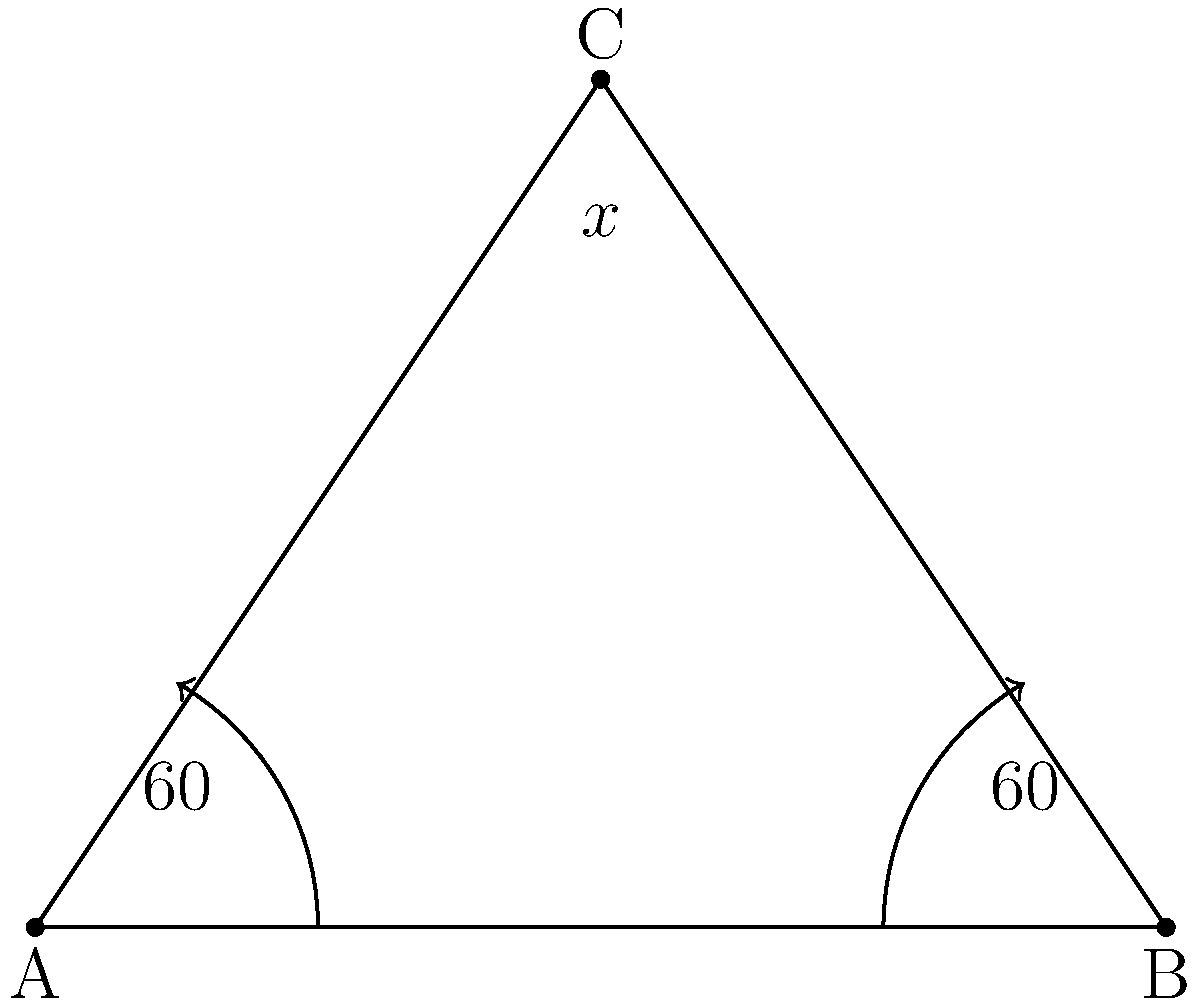In a movie theater, two spotlights are positioned at points A and B to illuminate a poster at point C. The angle between each spotlight beam and the ground is 60°. If the distance between the spotlights (AB) is 4 meters, what is the angle x° formed by the two spotlight beams at point C? Let's approach this step-by-step:

1) First, we need to recognize that this forms an isosceles triangle. Both spotlight beams form 60° angles with the ground, so the two sides AC and BC are equal.

2) In an isosceles triangle, the base angles are equal. Let's call each of these base angles y°.

3) We know that the sum of angles in a triangle is 180°. So we can write:

   $$60° + 60° + x° = 180°$$

4) Simplifying:

   $$120° + x° = 180°$$

5) Solving for x:

   $$x° = 180° - 120° = 60°$$

6) Therefore, the angle formed by the two spotlight beams at point C is 60°.

This setup creates a perfect equilateral triangle, which is fitting for illuminating a movie poster, as it provides balanced lighting from both sides.
Answer: 60° 